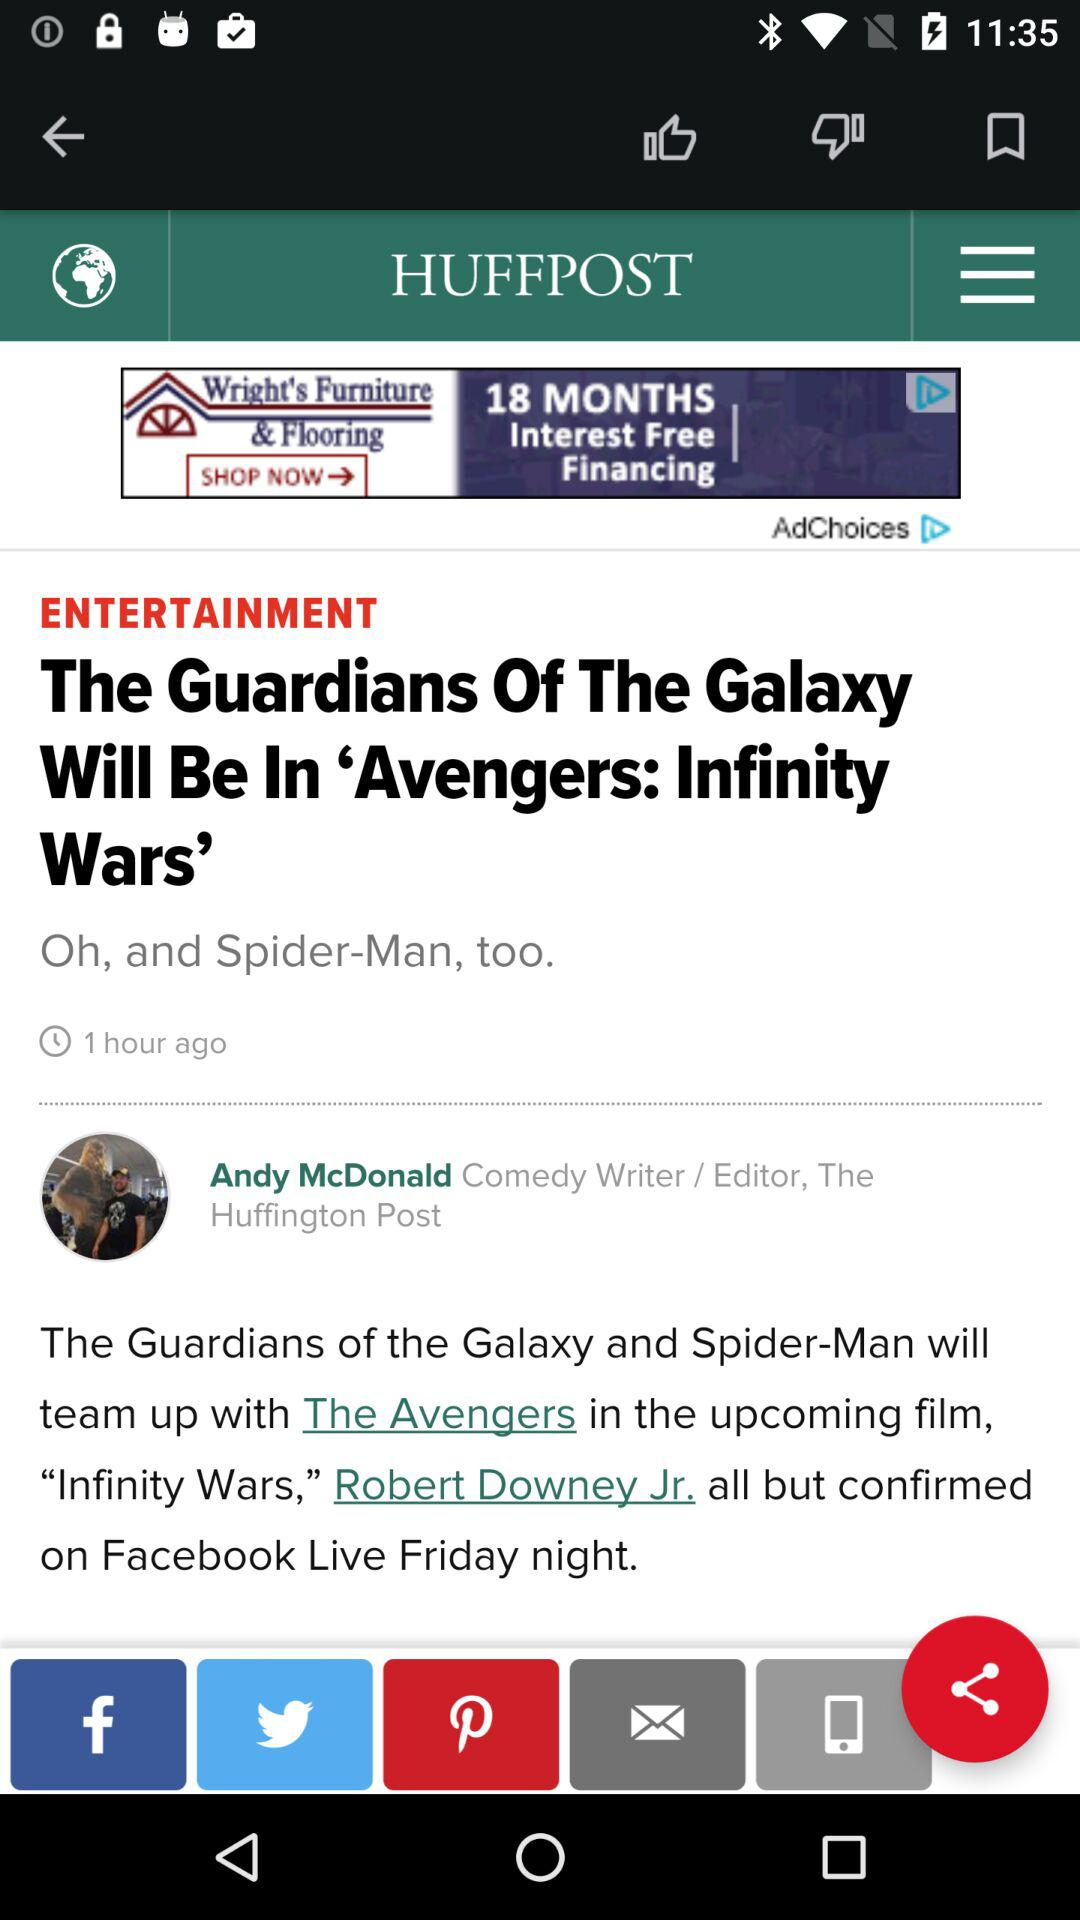Through which application can be share?
When the provided information is insufficient, respond with <no answer>. <no answer> 